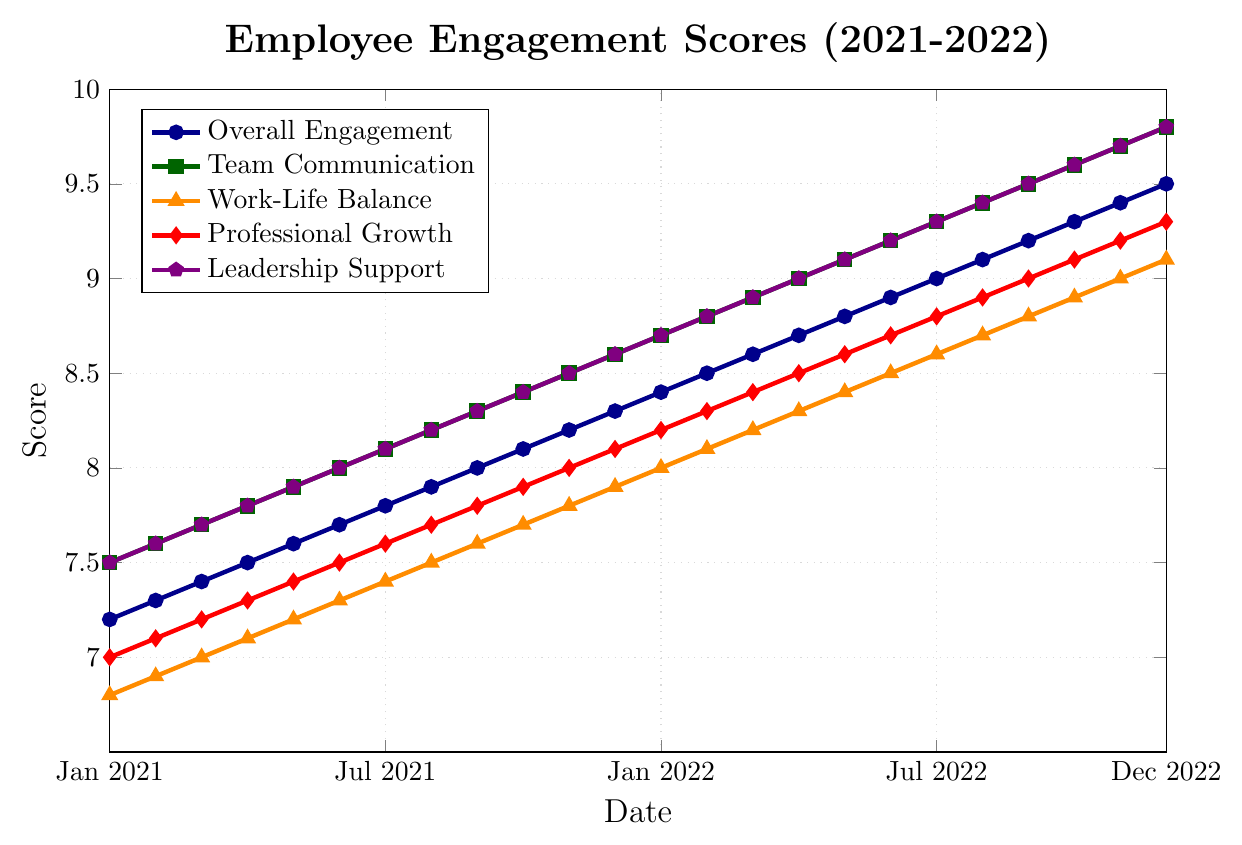What is the overall trend of the "Overall Engagement" score over the 2 years? The "Overall Engagement" score shows a steady increase from 7.2 in January 2021 to 9.5 in December 2022.
Answer: It increased steadily Which category had the highest score in January 2021? Looking at the markers for January 2021, "Team Communication" had the highest score of 7.5.
Answer: Team Communication In which month did "Work-Life Balance" first reach a score of 8.0 or higher? Referring to the "Work-Life Balance" (orange triangles), the score reaches 8.0 in December 2021 for the first time.
Answer: December 2021 How do the "Professional Growth" scores compare to "Leadership Support" scores in July 2022? In July 2022, "Professional Growth" has a score of 8.8, while "Leadership Support" has a score of 9.3. Comparing these values, "Leadership Support" is higher.
Answer: Leadership Support is higher What is the average "Team Communication" score for the year 2021? Summing the "Team Communication" scores for each month from January to December 2021 gives us a total of 94.2. Dividing by 12 gives an average score: 94.2/12 = 7.85.
Answer: 7.85 By how many points did the "Overall Engagement" score increase from January 2021 to December 2022? The "Overall Engagement" score increased from 7.2 in January 2021 to 9.5 in December 2022. The increase = 9.5 - 7.2 = 2.3 points.
Answer: 2.3 points Which category experienced the most significant increase from January 2021 to December 2022? "Work-Life Balance" increased from 6.8 to 9.1, giving an increase of 2.3 points. Checking the increases for other categories shows "Team Communication" increased by 2.3, "Professional Growth" by 2.3, and "Leadership Support" by 2.3 as well. But "Work-Life Balance" starts from the lowest base, making its relative change most significant.
Answer: Work-Life Balance During which month are "Professional Growth" and "Work-Life Balance" scores exactly equal? By examining each month visually and referring to the markers, in November 2021, both "Professional Growth" and "Work-Life Balance" are equal at a score of 8.0.
Answer: November 2021 Which category has the smallest variance in scores over the 2 years? To determine, visually check the range of fluctuations in each category. "Leadership Support" shows the least fluctuation as all scores consistently increase without large jumps or drops.
Answer: Leadership Support 